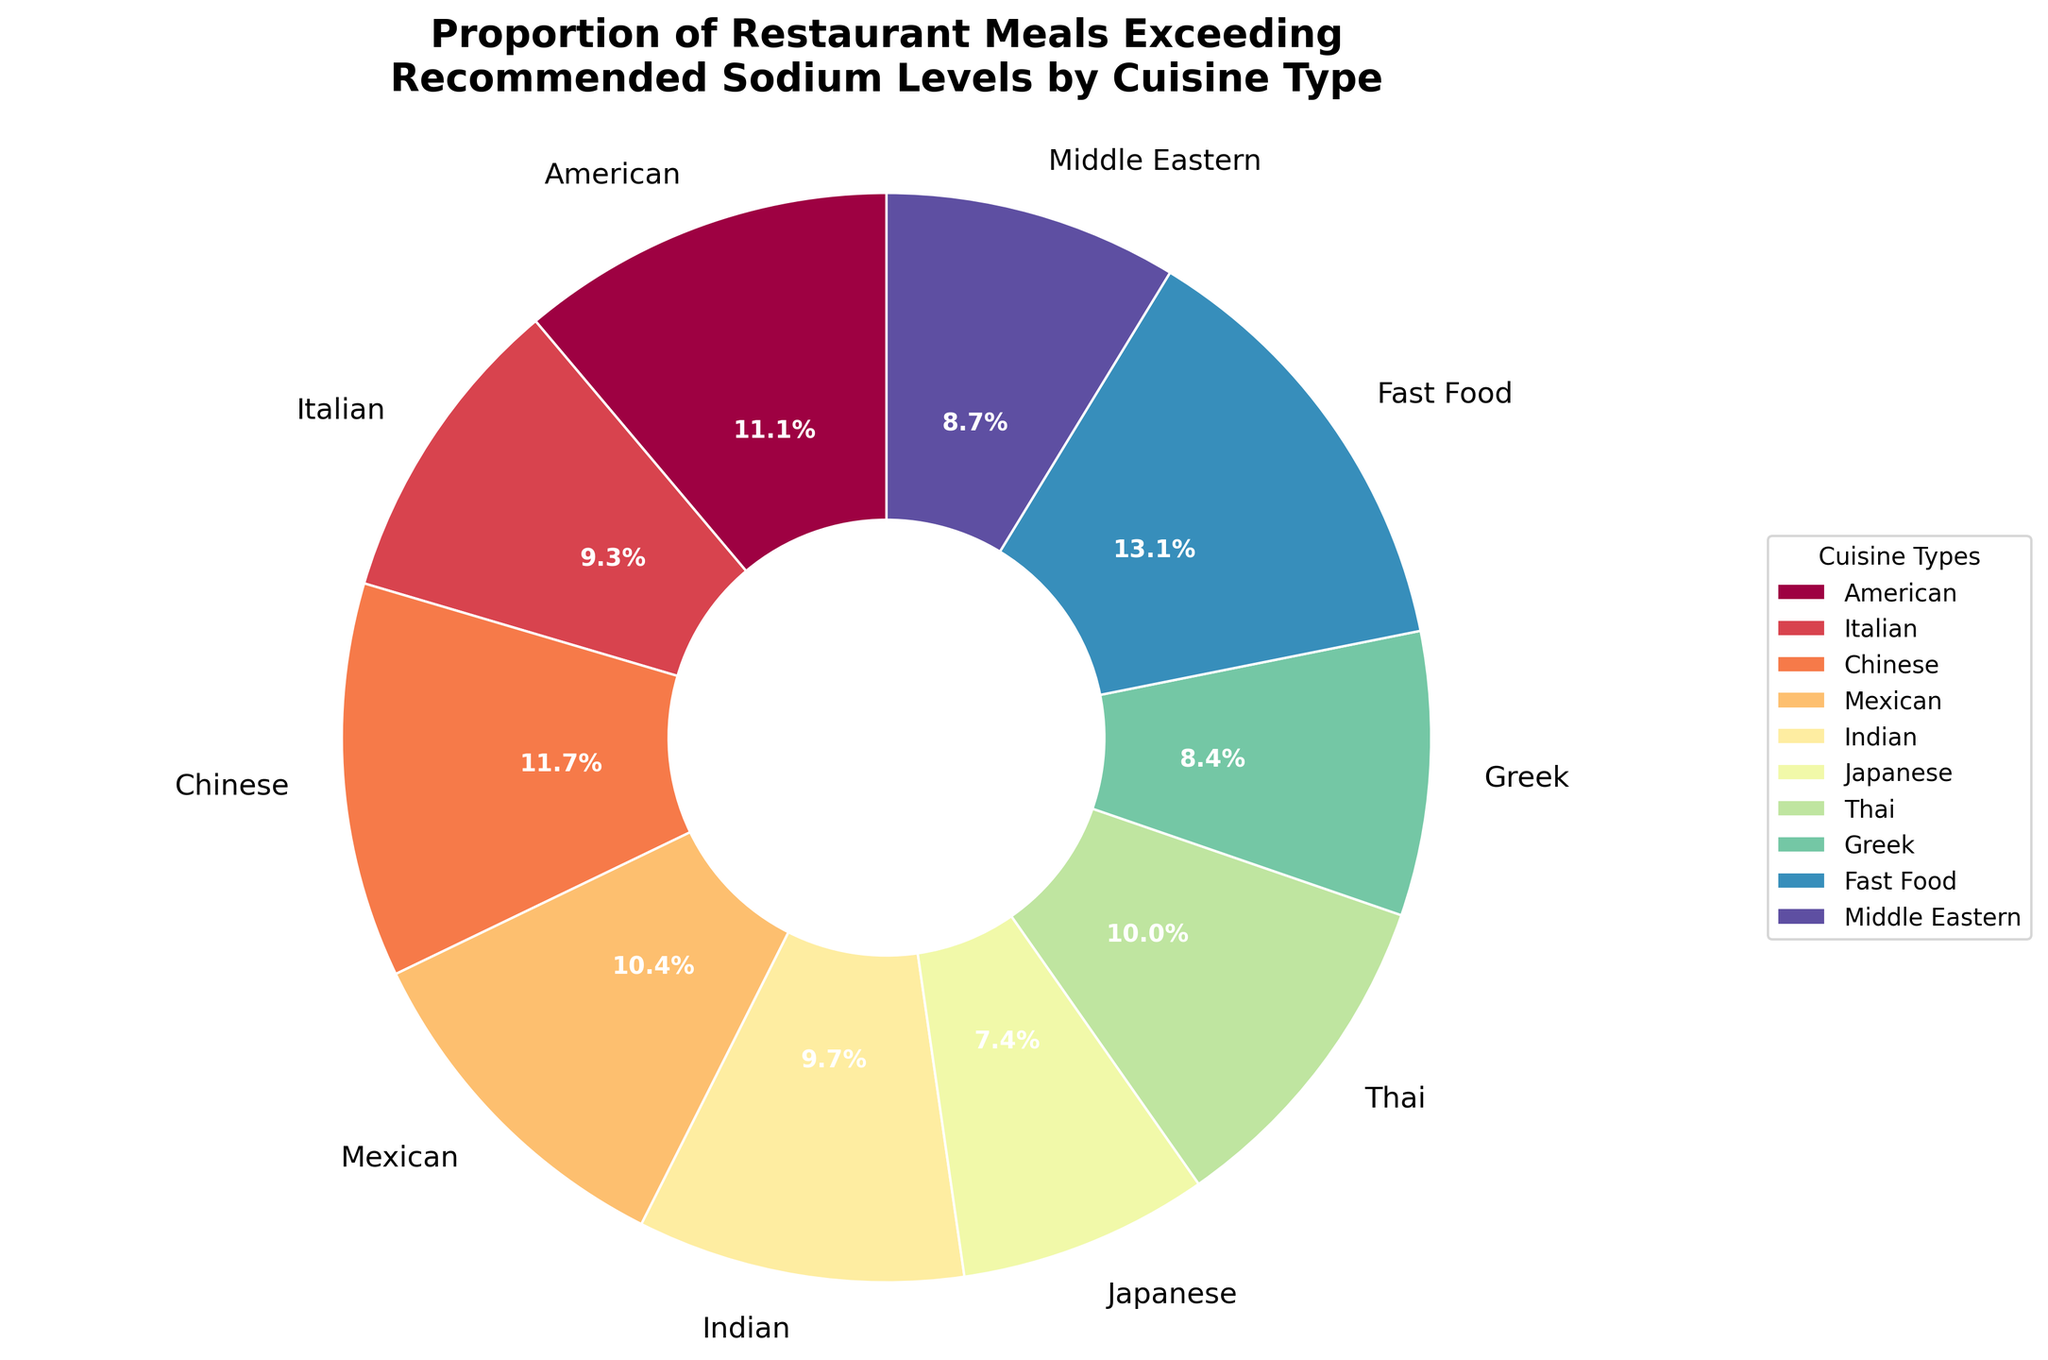Which cuisine type has the highest percentage of meals exceeding recommended sodium levels? The figure shows the breakdown of the percentage of meals exceeding sodium recommendations by cuisine type. Fast Food has the highest percentage.
Answer: Fast Food What is the difference in the percentage of meals exceeding recommended sodium levels between Chinese and Japanese cuisines? The percentage for Chinese cuisine is 82%, and for Japanese cuisine, it is 52%. The difference is 82% - 52%.
Answer: 30% Which cuisines have more than 70% of meals exceeding recommended sodium levels? From the chart segments, Fast Food, Chinese, American, and Mexican have percentages exceeding 70%.
Answer: Fast Food, Chinese, American, Mexican What proportion of cuisines have more than 60% but less than 80% of meals exceeding recommended sodium levels? From the pie chart, there are 10 cuisines in total. Those between 60% and 80% are American (78%), Italian (65%), Mexican (73%), Indian (68%), Thai (70%), and Middle Eastern (61%). That's 6/10.
Answer: 60% By how much does the proportion of Italian cuisine meals exceeding sodium levels differ from Greek cuisine meals? Italian meals exceed sodium recommendations by 65%, while Greek meals by 59%. The difference is 65% - 59%.
Answer: 6% Which type of cuisine falls below 60% in the proportion of meals exceeding recommended sodium levels? From the chart, Japanese cuisine is the only one with a percentage below 60%.
Answer: Japanese Compare the percentage of meals exceeding recommended sodium levels between Mexican and Thai cuisines. Which is higher and by how much? Mexican cuisine has 73%, and Thai has 70% of meals exceeding sodium levels. Mexican cuisine has a higher percentage by 73% - 70%.
Answer: Mexican by 3% Is the percentage of meals exceeding recommended sodium levels for Greek cuisine lower than that for Indian cuisine? Greek cuisine shows 59%, and Indian cuisine shows 68%. Since 59% is less than 68%, Greek is lower.
Answer: Yes Calculate the average proportion of meals exceeding recommended sodium levels for American, Italian, and Chinese cuisines. The percentages are American (78%), Italian (65%), and Chinese (82%). The average is (78 + 65 + 82) / 3 = 75%.
Answer: 75% How many cuisines have a percentage of meals exceeding sodium recommendations between 50% and 70%? The cuisines that fall within this range are Italian (65%), Indian (68%), Japanese (52%), Greek (59%), and Middle Eastern (61%). There are 5 such cuisines.
Answer: 5 